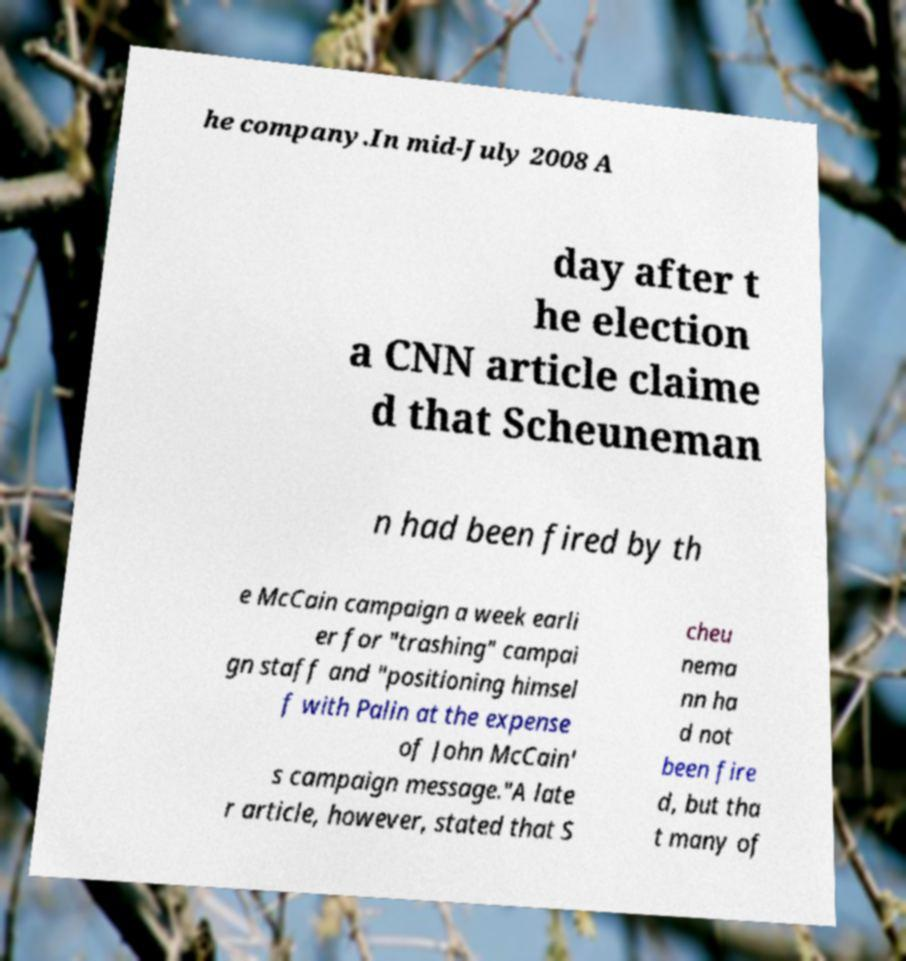For documentation purposes, I need the text within this image transcribed. Could you provide that? he company.In mid-July 2008 A day after t he election a CNN article claime d that Scheuneman n had been fired by th e McCain campaign a week earli er for "trashing" campai gn staff and "positioning himsel f with Palin at the expense of John McCain' s campaign message."A late r article, however, stated that S cheu nema nn ha d not been fire d, but tha t many of 